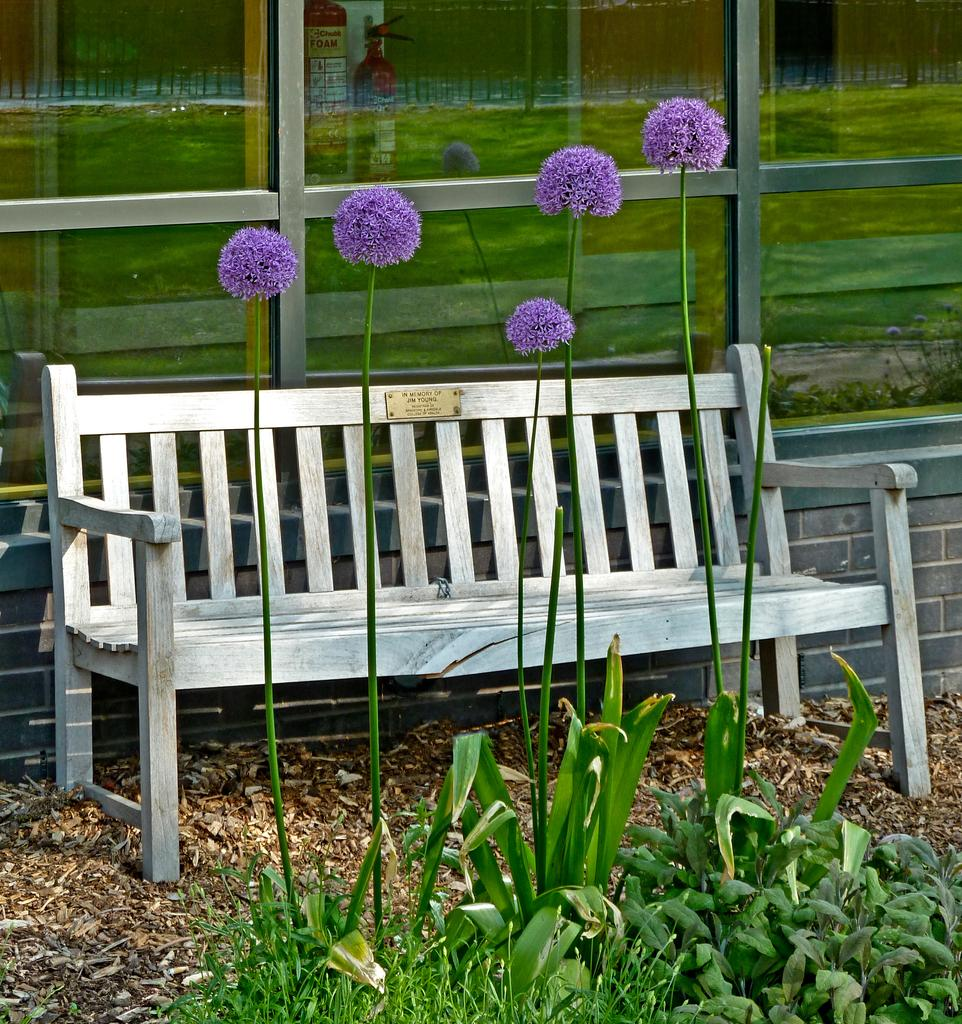What type of seating is visible in the image? There is a bench in the image. What can be seen on the ground near the bench? Dry leaves are present in the image. What type of vegetation is in the image? There is a plant and a flower in the image. What is visible behind the bench? There is a window behind the bench in the image. What type of meal is being prepared on the bench in the image? There is no meal preparation or cooking activity visible in the image; the bench is simply a seating object. 